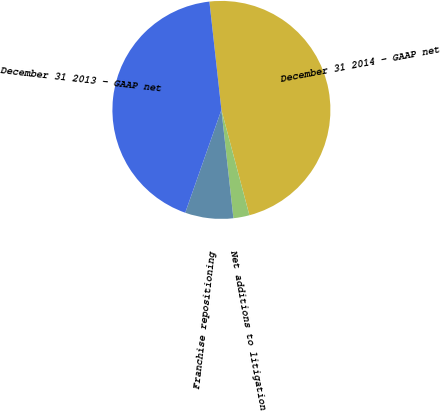Convert chart to OTSL. <chart><loc_0><loc_0><loc_500><loc_500><pie_chart><fcel>December 31 2014 - GAAP net<fcel>Net additions to litigation<fcel>Franchise repositioning<fcel>December 31 2013 - GAAP net<nl><fcel>47.62%<fcel>2.38%<fcel>7.14%<fcel>42.86%<nl></chart> 